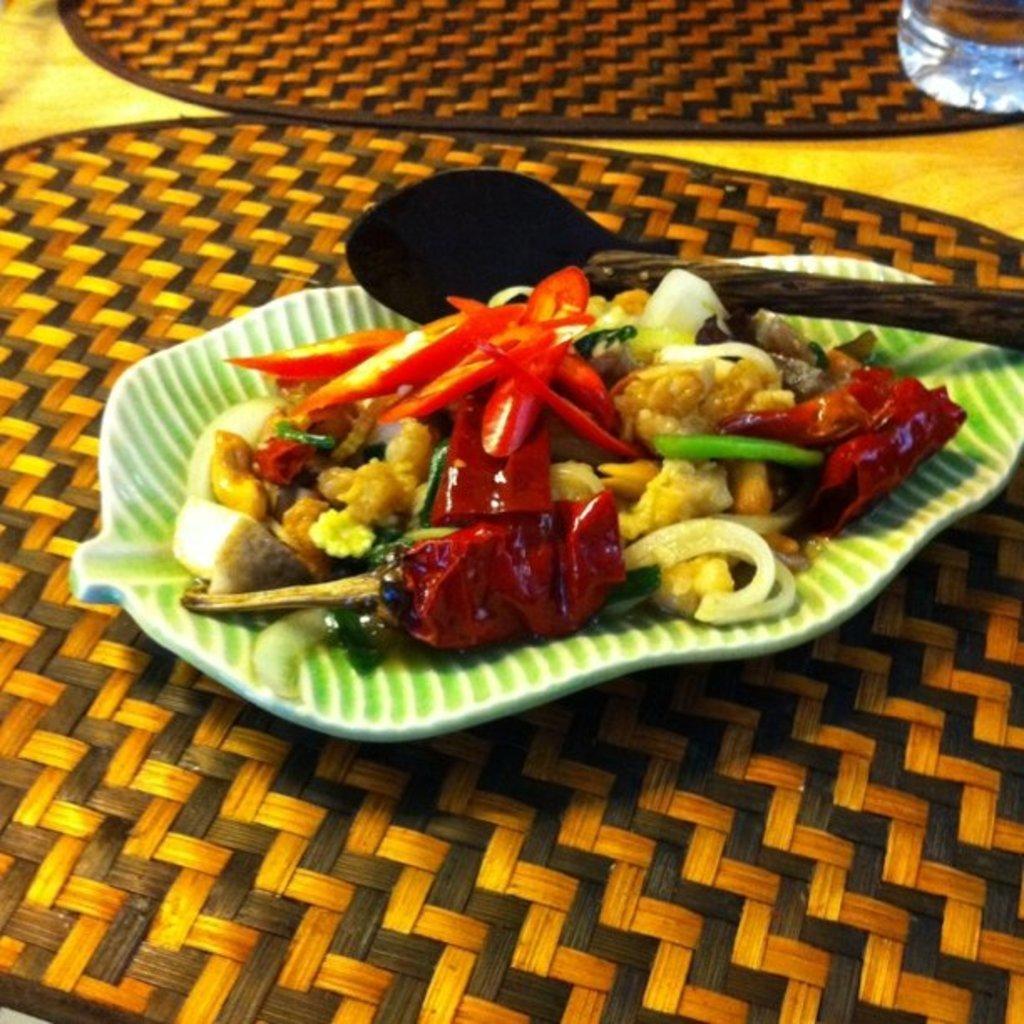Please provide a concise description of this image. In this image I can see food item with spoon on a plate, which is placed on a table mat. Also there is another mat and in the top right corner it looks like a glass of water. 